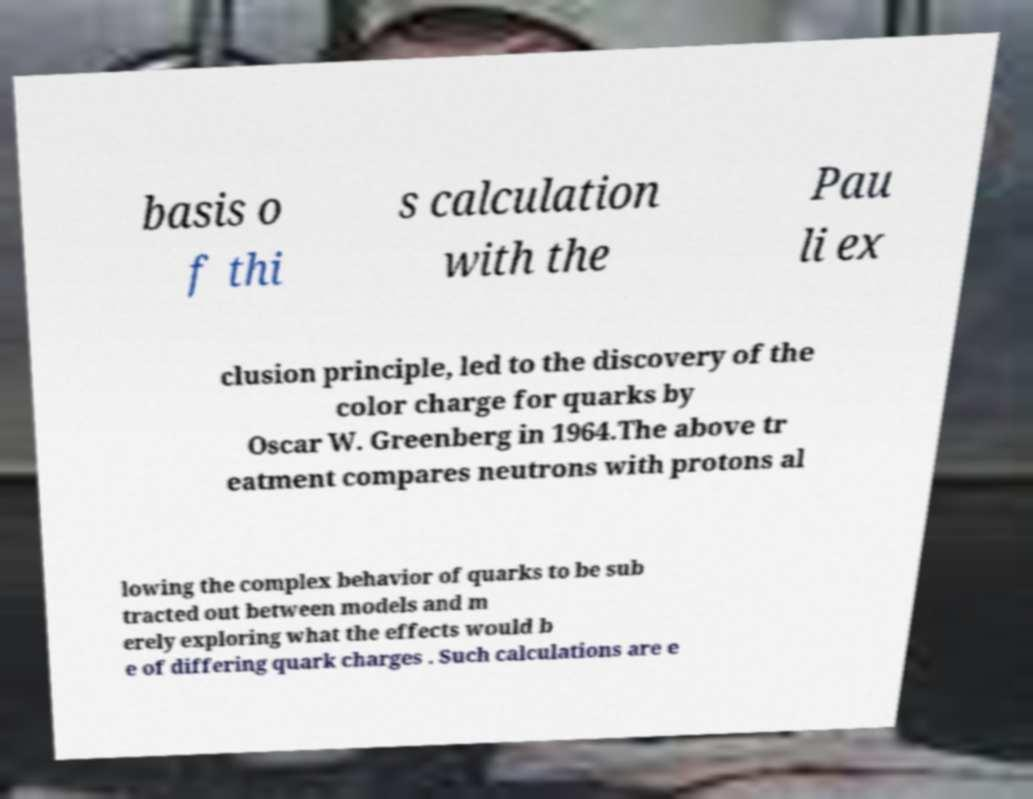Could you extract and type out the text from this image? basis o f thi s calculation with the Pau li ex clusion principle, led to the discovery of the color charge for quarks by Oscar W. Greenberg in 1964.The above tr eatment compares neutrons with protons al lowing the complex behavior of quarks to be sub tracted out between models and m erely exploring what the effects would b e of differing quark charges . Such calculations are e 